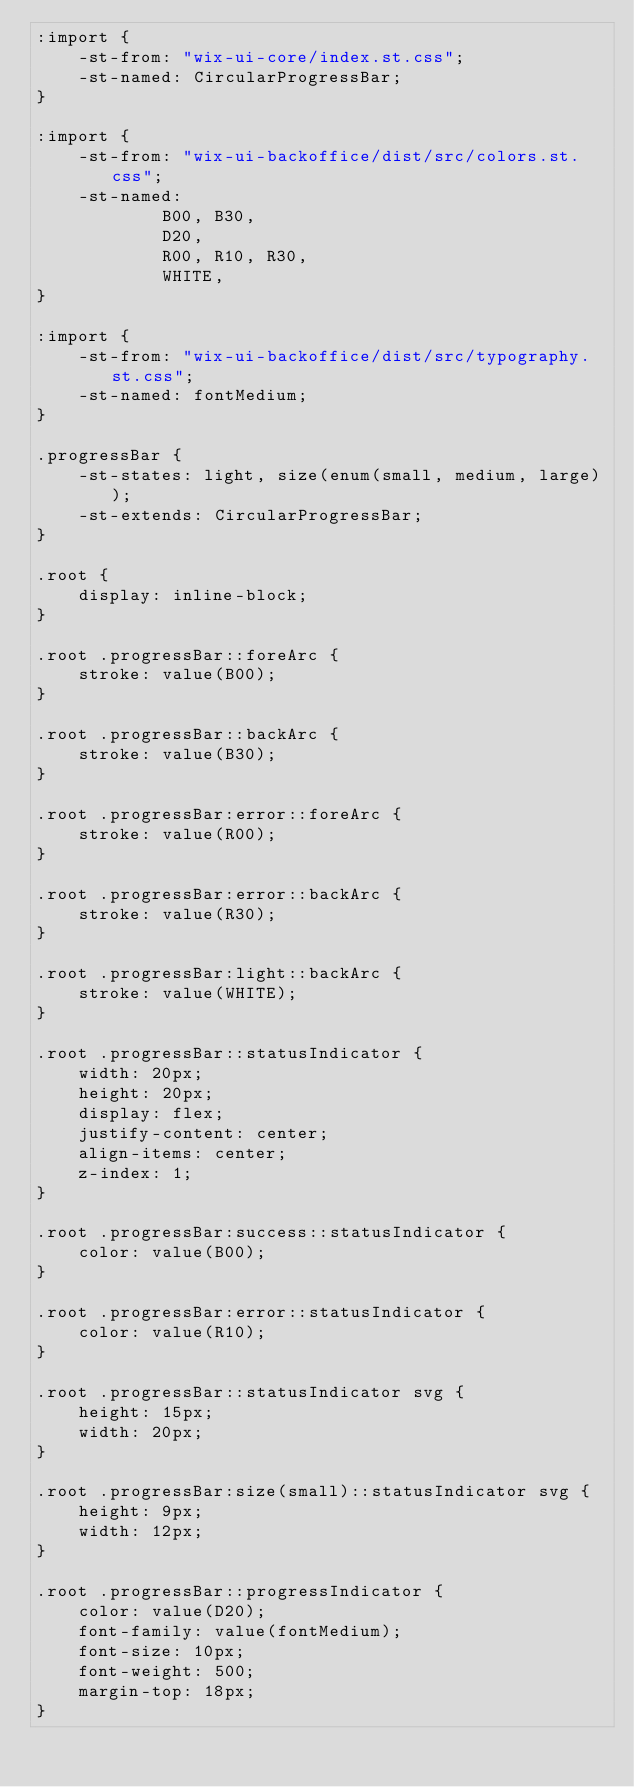<code> <loc_0><loc_0><loc_500><loc_500><_CSS_>:import {
    -st-from: "wix-ui-core/index.st.css";
    -st-named: CircularProgressBar;
}

:import {
    -st-from: "wix-ui-backoffice/dist/src/colors.st.css";
    -st-named:
            B00, B30,
            D20,
            R00, R10, R30,
            WHITE,
}

:import {
    -st-from: "wix-ui-backoffice/dist/src/typography.st.css";
    -st-named: fontMedium;
}

.progressBar {
    -st-states: light, size(enum(small, medium, large));
    -st-extends: CircularProgressBar;
}

.root {
    display: inline-block;
}

.root .progressBar::foreArc {
    stroke: value(B00);
}

.root .progressBar::backArc {
    stroke: value(B30);
}

.root .progressBar:error::foreArc {
    stroke: value(R00);
}

.root .progressBar:error::backArc {
    stroke: value(R30);
}

.root .progressBar:light::backArc {
    stroke: value(WHITE);
}

.root .progressBar::statusIndicator {
    width: 20px;
    height: 20px;
    display: flex;
    justify-content: center;
    align-items: center;
    z-index: 1;
}

.root .progressBar:success::statusIndicator {
    color: value(B00);
}

.root .progressBar:error::statusIndicator {
    color: value(R10);
}

.root .progressBar::statusIndicator svg {
    height: 15px;
    width: 20px;
}

.root .progressBar:size(small)::statusIndicator svg {
    height: 9px;
    width: 12px;
}

.root .progressBar::progressIndicator {
    color: value(D20);
    font-family: value(fontMedium);
    font-size: 10px;
    font-weight: 500;
    margin-top: 18px;
}

</code> 